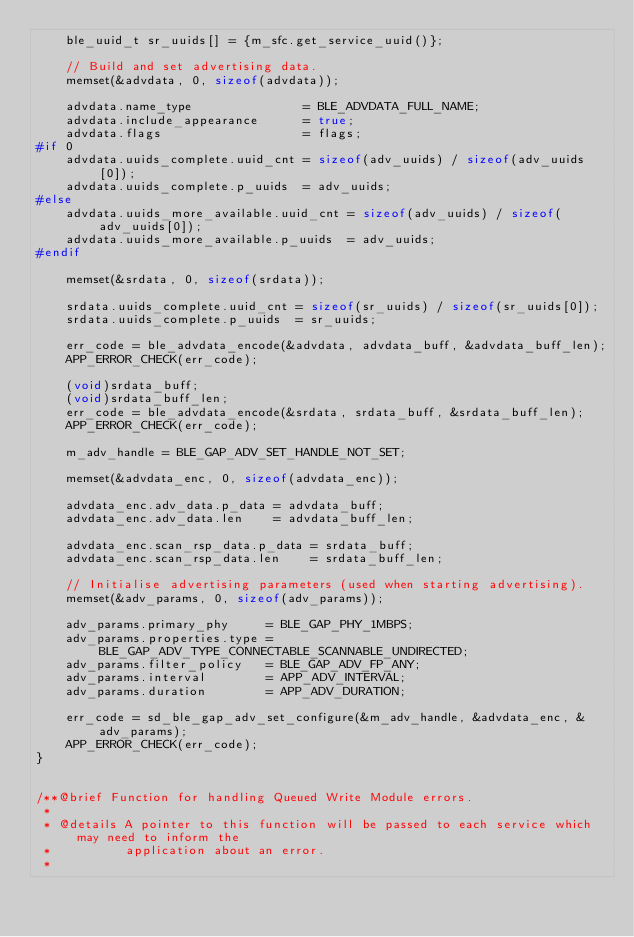<code> <loc_0><loc_0><loc_500><loc_500><_C++_>    ble_uuid_t sr_uuids[] = {m_sfc.get_service_uuid()};

    // Build and set advertising data.
    memset(&advdata, 0, sizeof(advdata));

    advdata.name_type               = BLE_ADVDATA_FULL_NAME;
    advdata.include_appearance      = true;
    advdata.flags                   = flags;
#if 0
    advdata.uuids_complete.uuid_cnt = sizeof(adv_uuids) / sizeof(adv_uuids[0]);
    advdata.uuids_complete.p_uuids  = adv_uuids;
#else
    advdata.uuids_more_available.uuid_cnt = sizeof(adv_uuids) / sizeof(adv_uuids[0]);
    advdata.uuids_more_available.p_uuids  = adv_uuids;
#endif
    
    memset(&srdata, 0, sizeof(srdata));

    srdata.uuids_complete.uuid_cnt = sizeof(sr_uuids) / sizeof(sr_uuids[0]);
    srdata.uuids_complete.p_uuids  = sr_uuids;

    err_code = ble_advdata_encode(&advdata, advdata_buff, &advdata_buff_len);
    APP_ERROR_CHECK(err_code);

    (void)srdata_buff;
    (void)srdata_buff_len;
    err_code = ble_advdata_encode(&srdata, srdata_buff, &srdata_buff_len);
    APP_ERROR_CHECK(err_code);

    m_adv_handle = BLE_GAP_ADV_SET_HANDLE_NOT_SET;

    memset(&advdata_enc, 0, sizeof(advdata_enc));

    advdata_enc.adv_data.p_data = advdata_buff;
    advdata_enc.adv_data.len    = advdata_buff_len;

    advdata_enc.scan_rsp_data.p_data = srdata_buff;
    advdata_enc.scan_rsp_data.len    = srdata_buff_len;

    // Initialise advertising parameters (used when starting advertising).
    memset(&adv_params, 0, sizeof(adv_params));

    adv_params.primary_phy     = BLE_GAP_PHY_1MBPS;
    adv_params.properties.type = BLE_GAP_ADV_TYPE_CONNECTABLE_SCANNABLE_UNDIRECTED;
    adv_params.filter_policy   = BLE_GAP_ADV_FP_ANY;
    adv_params.interval        = APP_ADV_INTERVAL;
    adv_params.duration        = APP_ADV_DURATION;

    err_code = sd_ble_gap_adv_set_configure(&m_adv_handle, &advdata_enc, &adv_params);
    APP_ERROR_CHECK(err_code);
}


/**@brief Function for handling Queued Write Module errors.
 *
 * @details A pointer to this function will be passed to each service which may need to inform the
 *          application about an error.
 *</code> 